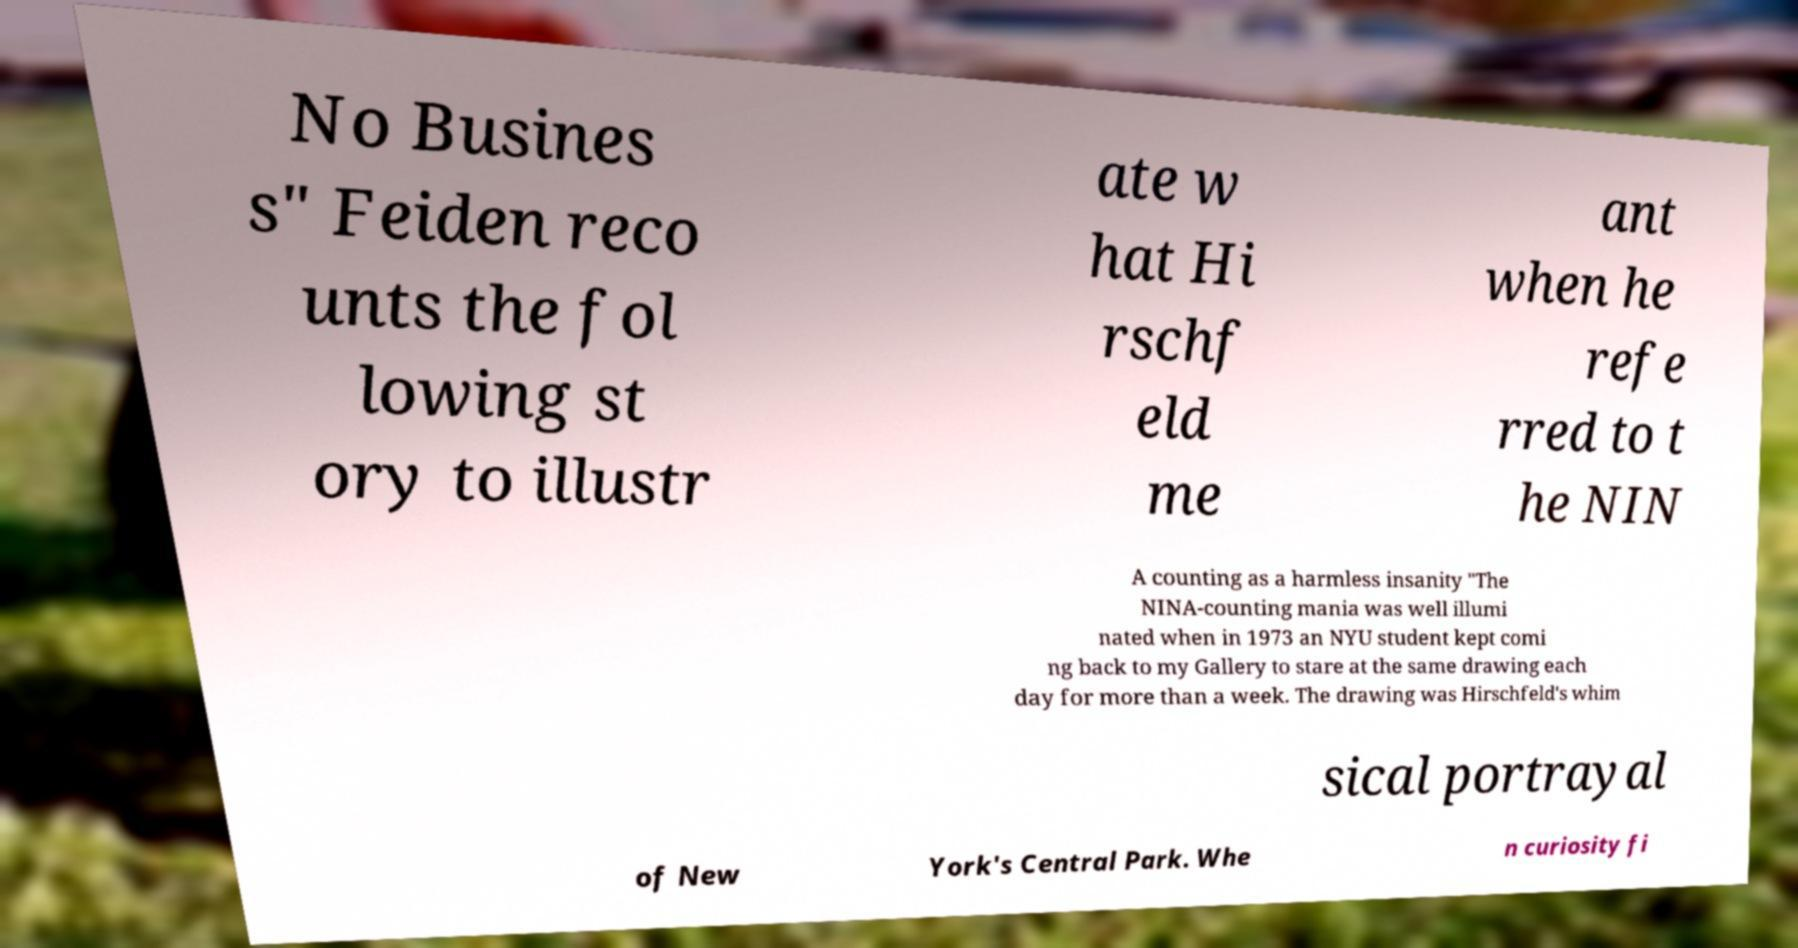Could you extract and type out the text from this image? No Busines s" Feiden reco unts the fol lowing st ory to illustr ate w hat Hi rschf eld me ant when he refe rred to t he NIN A counting as a harmless insanity "The NINA-counting mania was well illumi nated when in 1973 an NYU student kept comi ng back to my Gallery to stare at the same drawing each day for more than a week. The drawing was Hirschfeld's whim sical portrayal of New York's Central Park. Whe n curiosity fi 